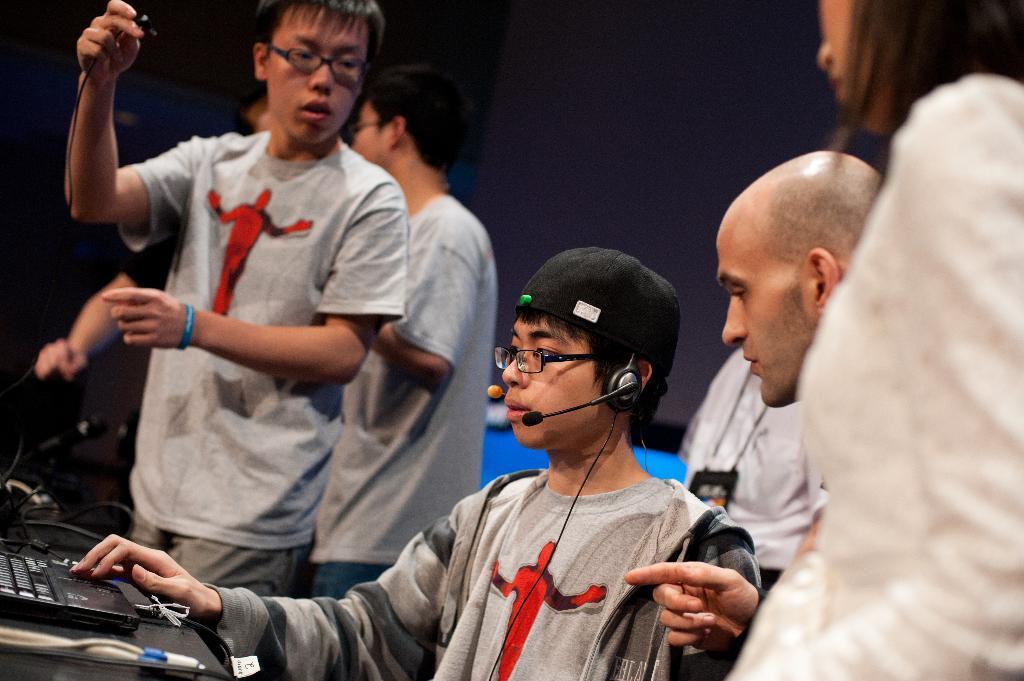Please provide a concise description of this image. In this image I can see group of people. There are microphones, cables and some other objects. And the background is blurry. 